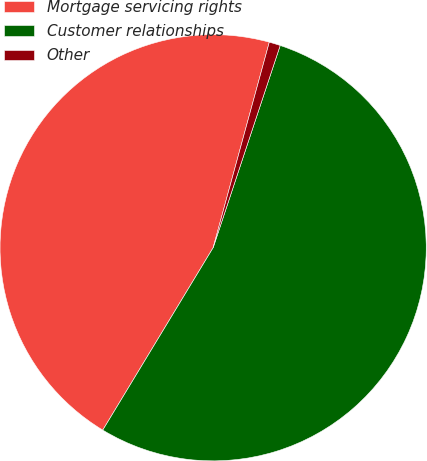Convert chart to OTSL. <chart><loc_0><loc_0><loc_500><loc_500><pie_chart><fcel>Mortgage servicing rights<fcel>Customer relationships<fcel>Other<nl><fcel>45.58%<fcel>53.56%<fcel>0.85%<nl></chart> 